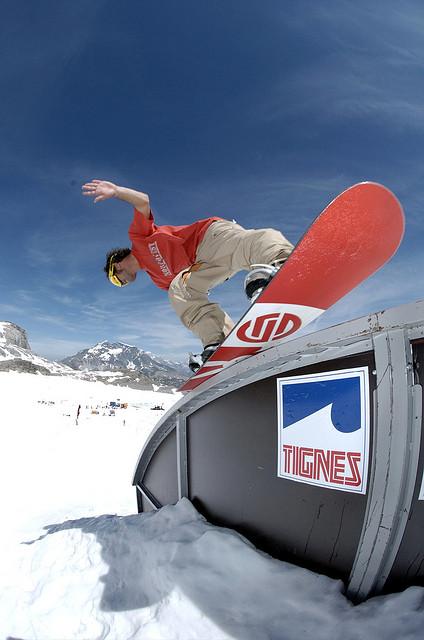What is the man's feet on?
Give a very brief answer. Snowboard. Why isn't he wearing a jacket?
Short answer required. Warm. What color is the man's shirt?
Write a very short answer. Red. 